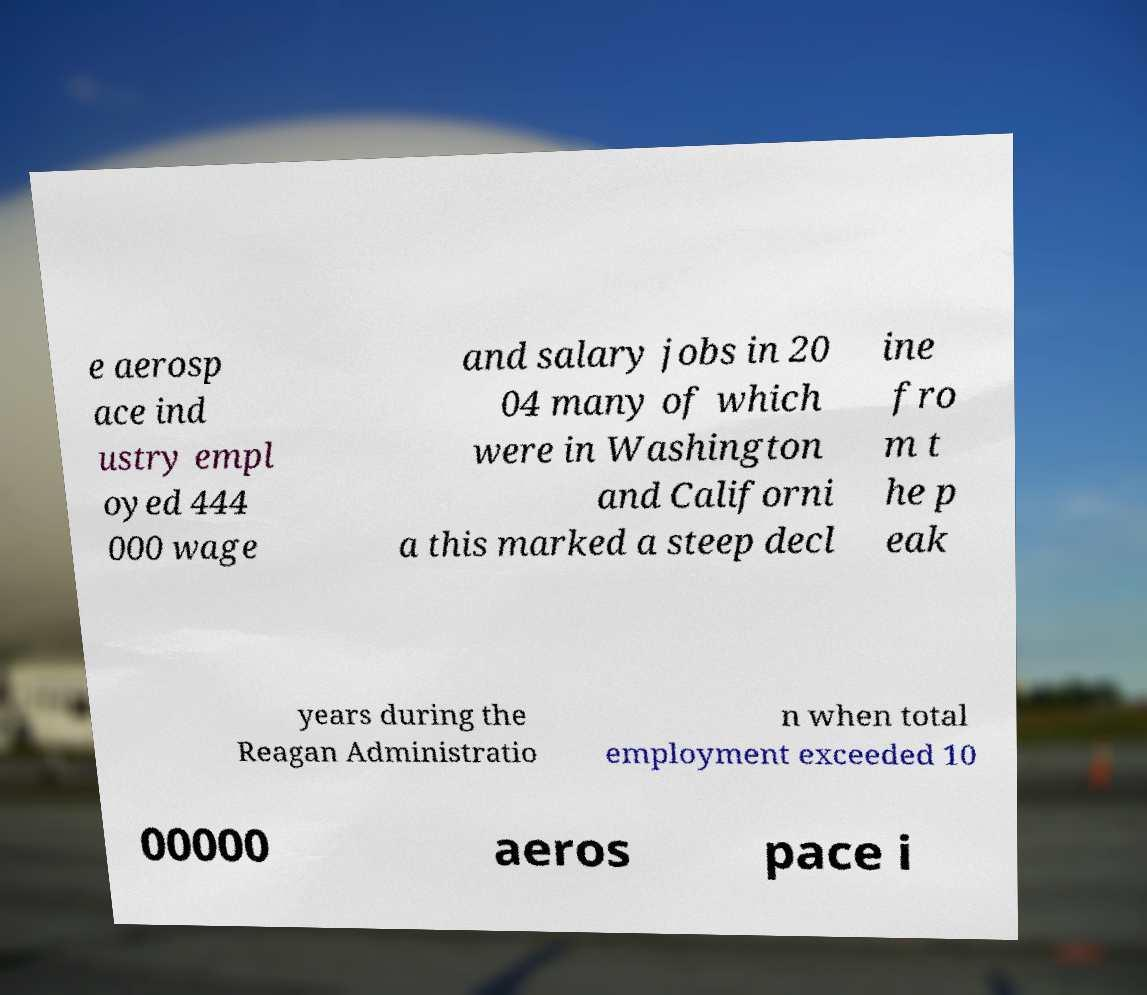Please identify and transcribe the text found in this image. e aerosp ace ind ustry empl oyed 444 000 wage and salary jobs in 20 04 many of which were in Washington and Californi a this marked a steep decl ine fro m t he p eak years during the Reagan Administratio n when total employment exceeded 10 00000 aeros pace i 